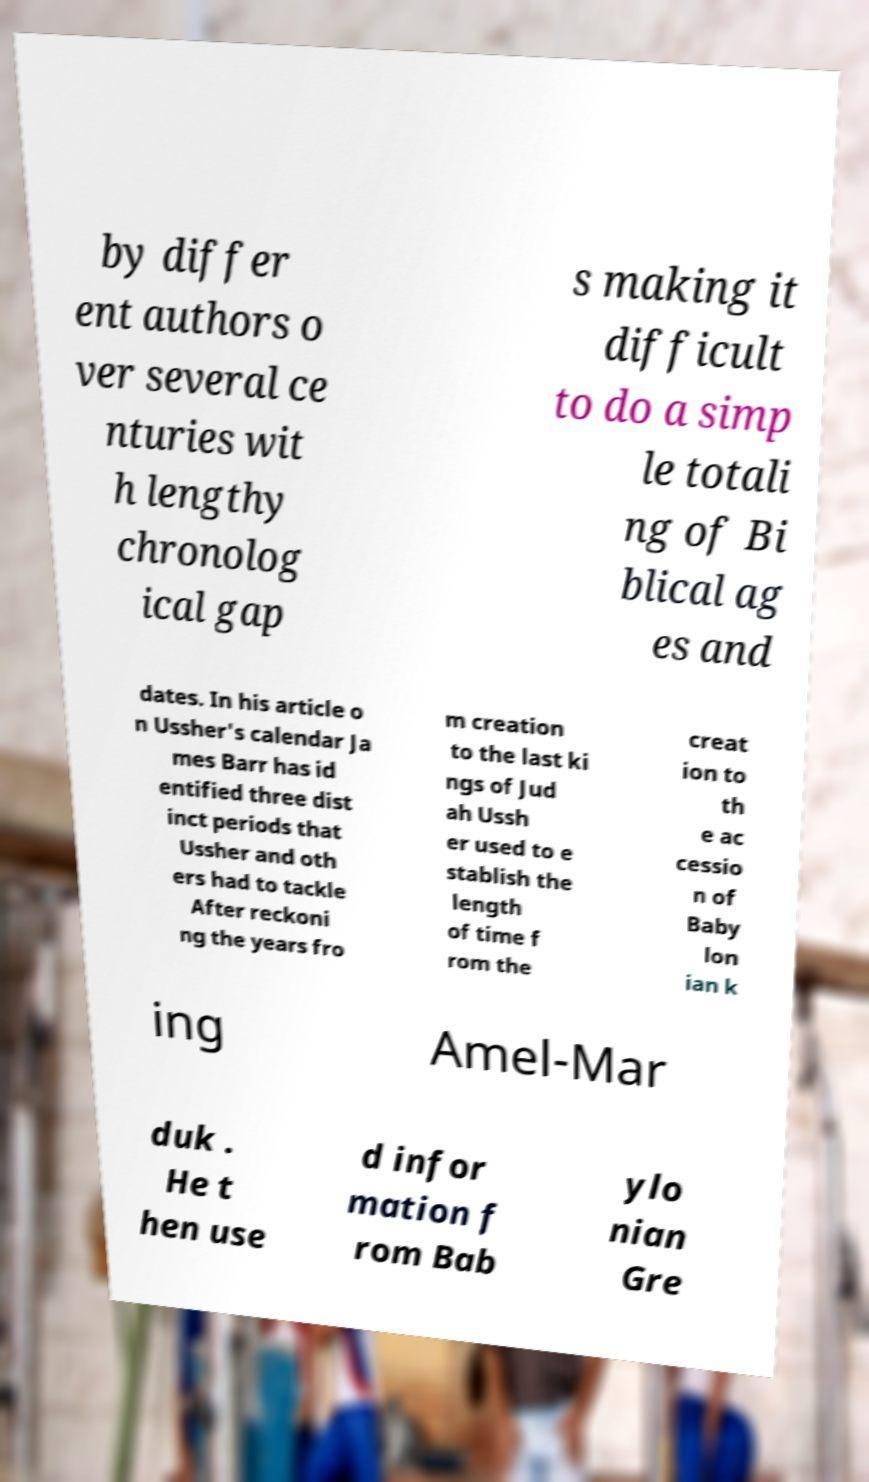Could you assist in decoding the text presented in this image and type it out clearly? by differ ent authors o ver several ce nturies wit h lengthy chronolog ical gap s making it difficult to do a simp le totali ng of Bi blical ag es and dates. In his article o n Ussher's calendar Ja mes Barr has id entified three dist inct periods that Ussher and oth ers had to tackle After reckoni ng the years fro m creation to the last ki ngs of Jud ah Ussh er used to e stablish the length of time f rom the creat ion to th e ac cessio n of Baby lon ian k ing Amel-Mar duk . He t hen use d infor mation f rom Bab ylo nian Gre 